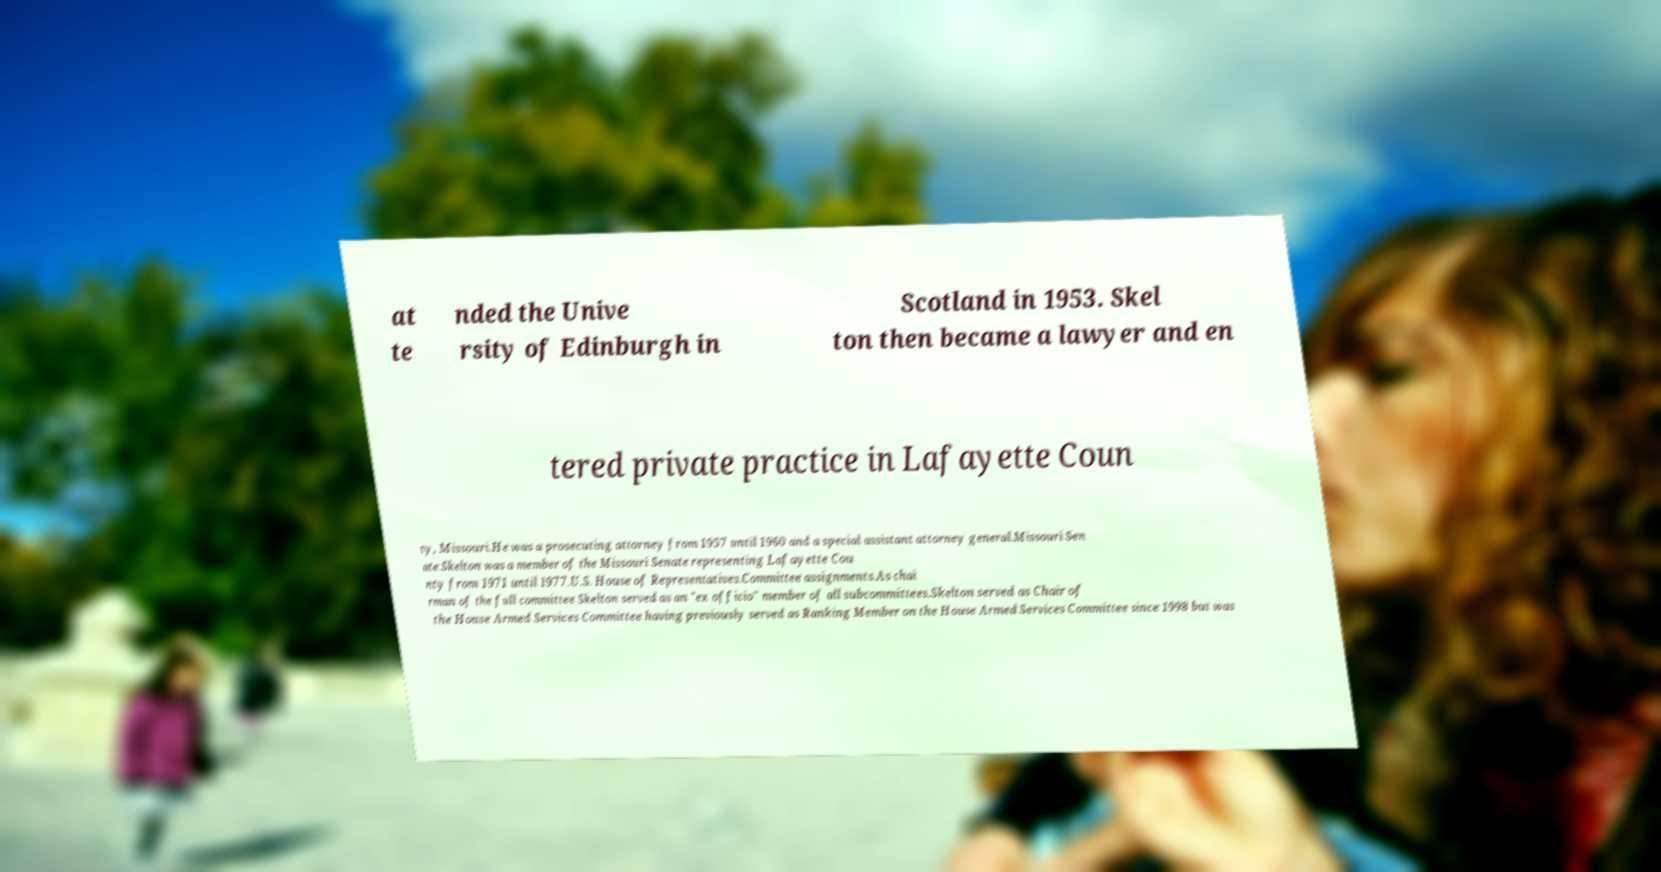Could you extract and type out the text from this image? at te nded the Unive rsity of Edinburgh in Scotland in 1953. Skel ton then became a lawyer and en tered private practice in Lafayette Coun ty, Missouri.He was a prosecuting attorney from 1957 until 1960 and a special assistant attorney general.Missouri Sen ate.Skelton was a member of the Missouri Senate representing Lafayette Cou nty from 1971 until 1977.U.S. House of Representatives.Committee assignments.As chai rman of the full committee Skelton served as an "ex officio" member of all subcommittees.Skelton served as Chair of the House Armed Services Committee having previously served as Ranking Member on the House Armed Services Committee since 1998 but was 